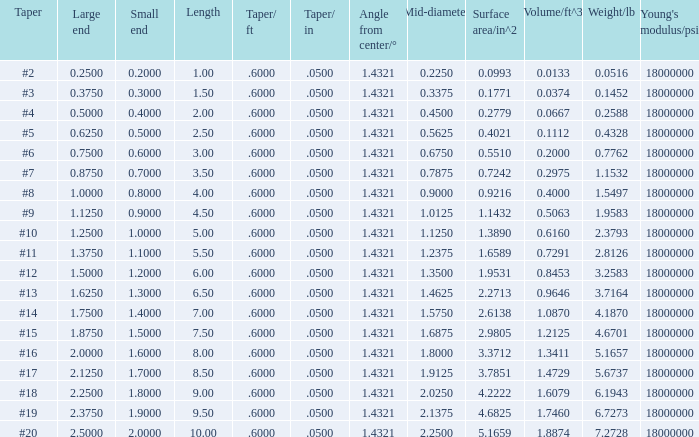Which Large end has a Taper/ft smaller than 0.6000000000000001? 19.0. 